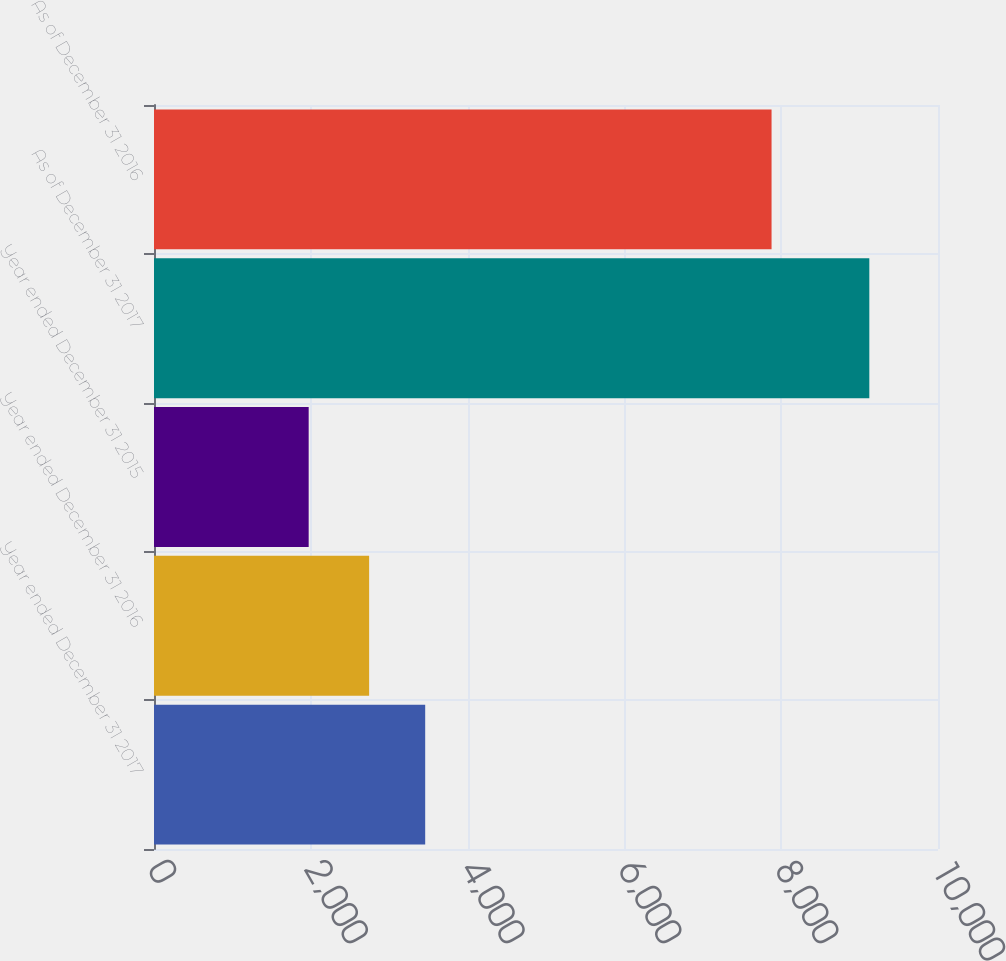<chart> <loc_0><loc_0><loc_500><loc_500><bar_chart><fcel>Year ended December 31 2017<fcel>Year ended December 31 2016<fcel>Year ended December 31 2015<fcel>As of December 31 2017<fcel>As of December 31 2016<nl><fcel>3459.1<fcel>2744<fcel>1973<fcel>9124<fcel>7877<nl></chart> 